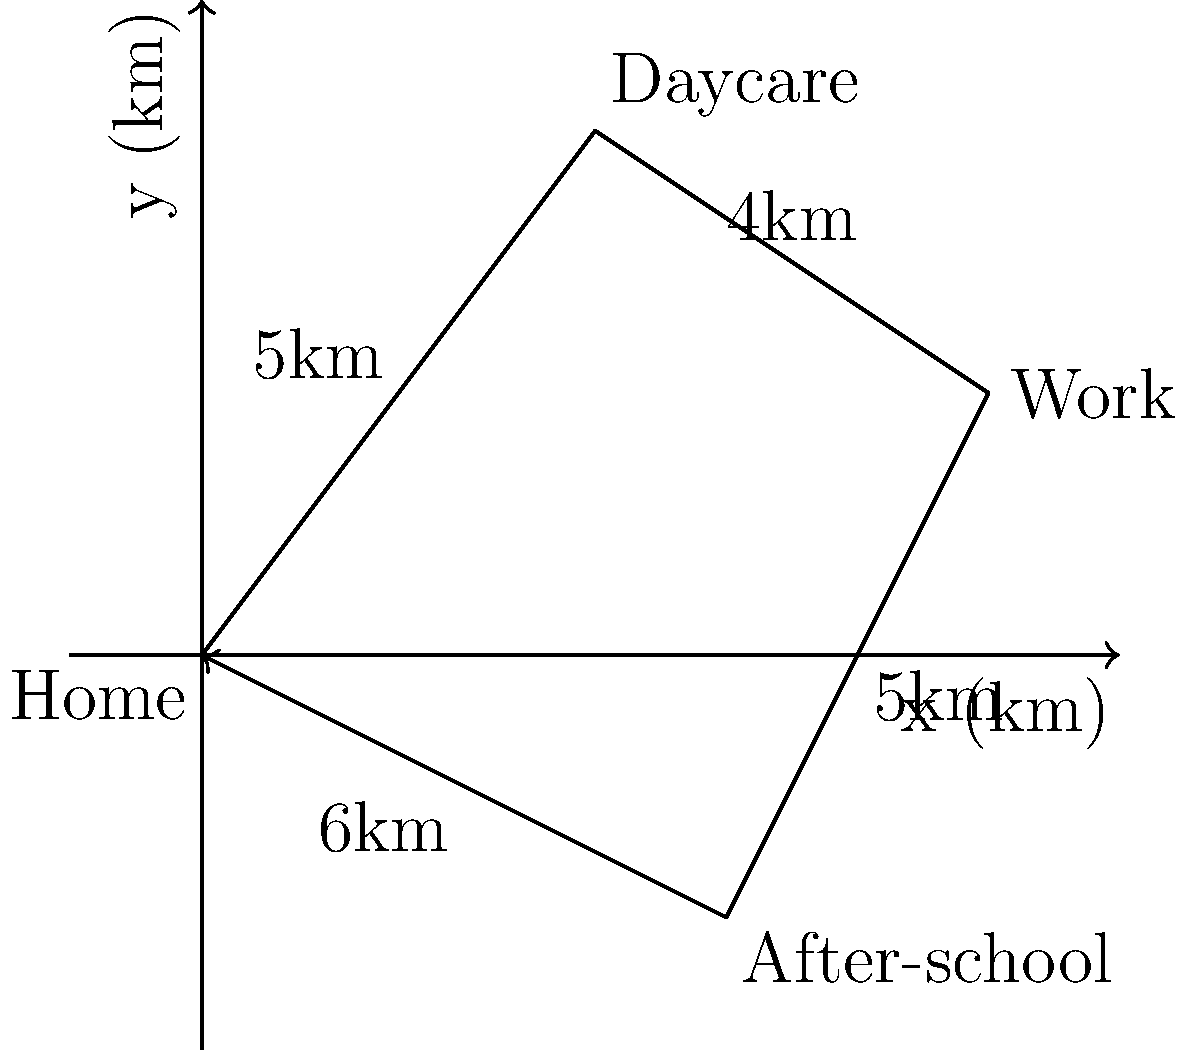A single mother needs to optimize her daily routine, which includes dropping her child at daycare, going to work, picking up her child from after-school activities, and returning home. Given the map showing the locations and distances between these points, what is the total distance traveled in kilometers if she follows the most efficient route? To solve this problem, we need to follow these steps:

1. Identify the given locations and distances:
   - Home to Daycare: 5 km
   - Daycare to Work: 4 km
   - Work to After-school: 5 km
   - After-school to Home: 6 km

2. Determine the most efficient route:
   The most efficient route is to visit each location once in the order that minimizes backtracking. In this case, the optimal route is:
   Home → Daycare → Work → After-school → Home

3. Calculate the total distance:
   - Home to Daycare: 5 km
   - Daycare to Work: 4 km
   - Work to After-school: 5 km
   - After-school to Home: 6 km

4. Sum up the distances:
   Total distance = 5 + 4 + 5 + 6 = 20 km

Therefore, the total distance traveled following the most efficient route is 20 kilometers.
Answer: 20 km 